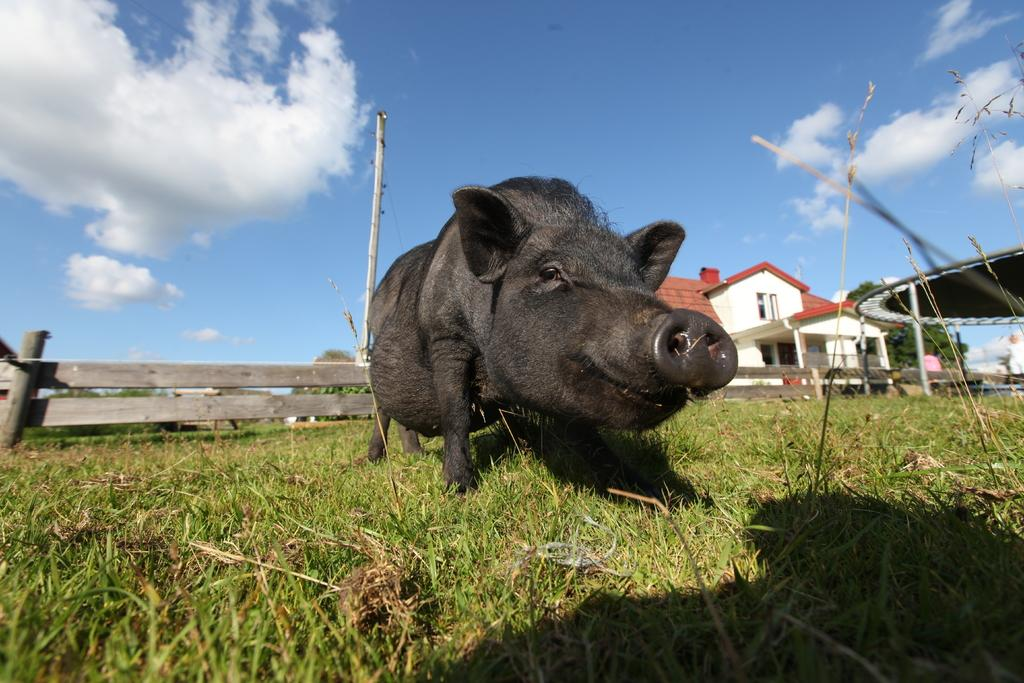What animal is on the grass in the image? There is a pig on the grass in the image. What can be seen in the background of the image? There is a house, a wooden fence, a wooden pole, a tree, and the sky visible in the background. What type of noise is the pig making in the image? The image does not provide any information about the pig's noise, so it cannot be determined from the image. 